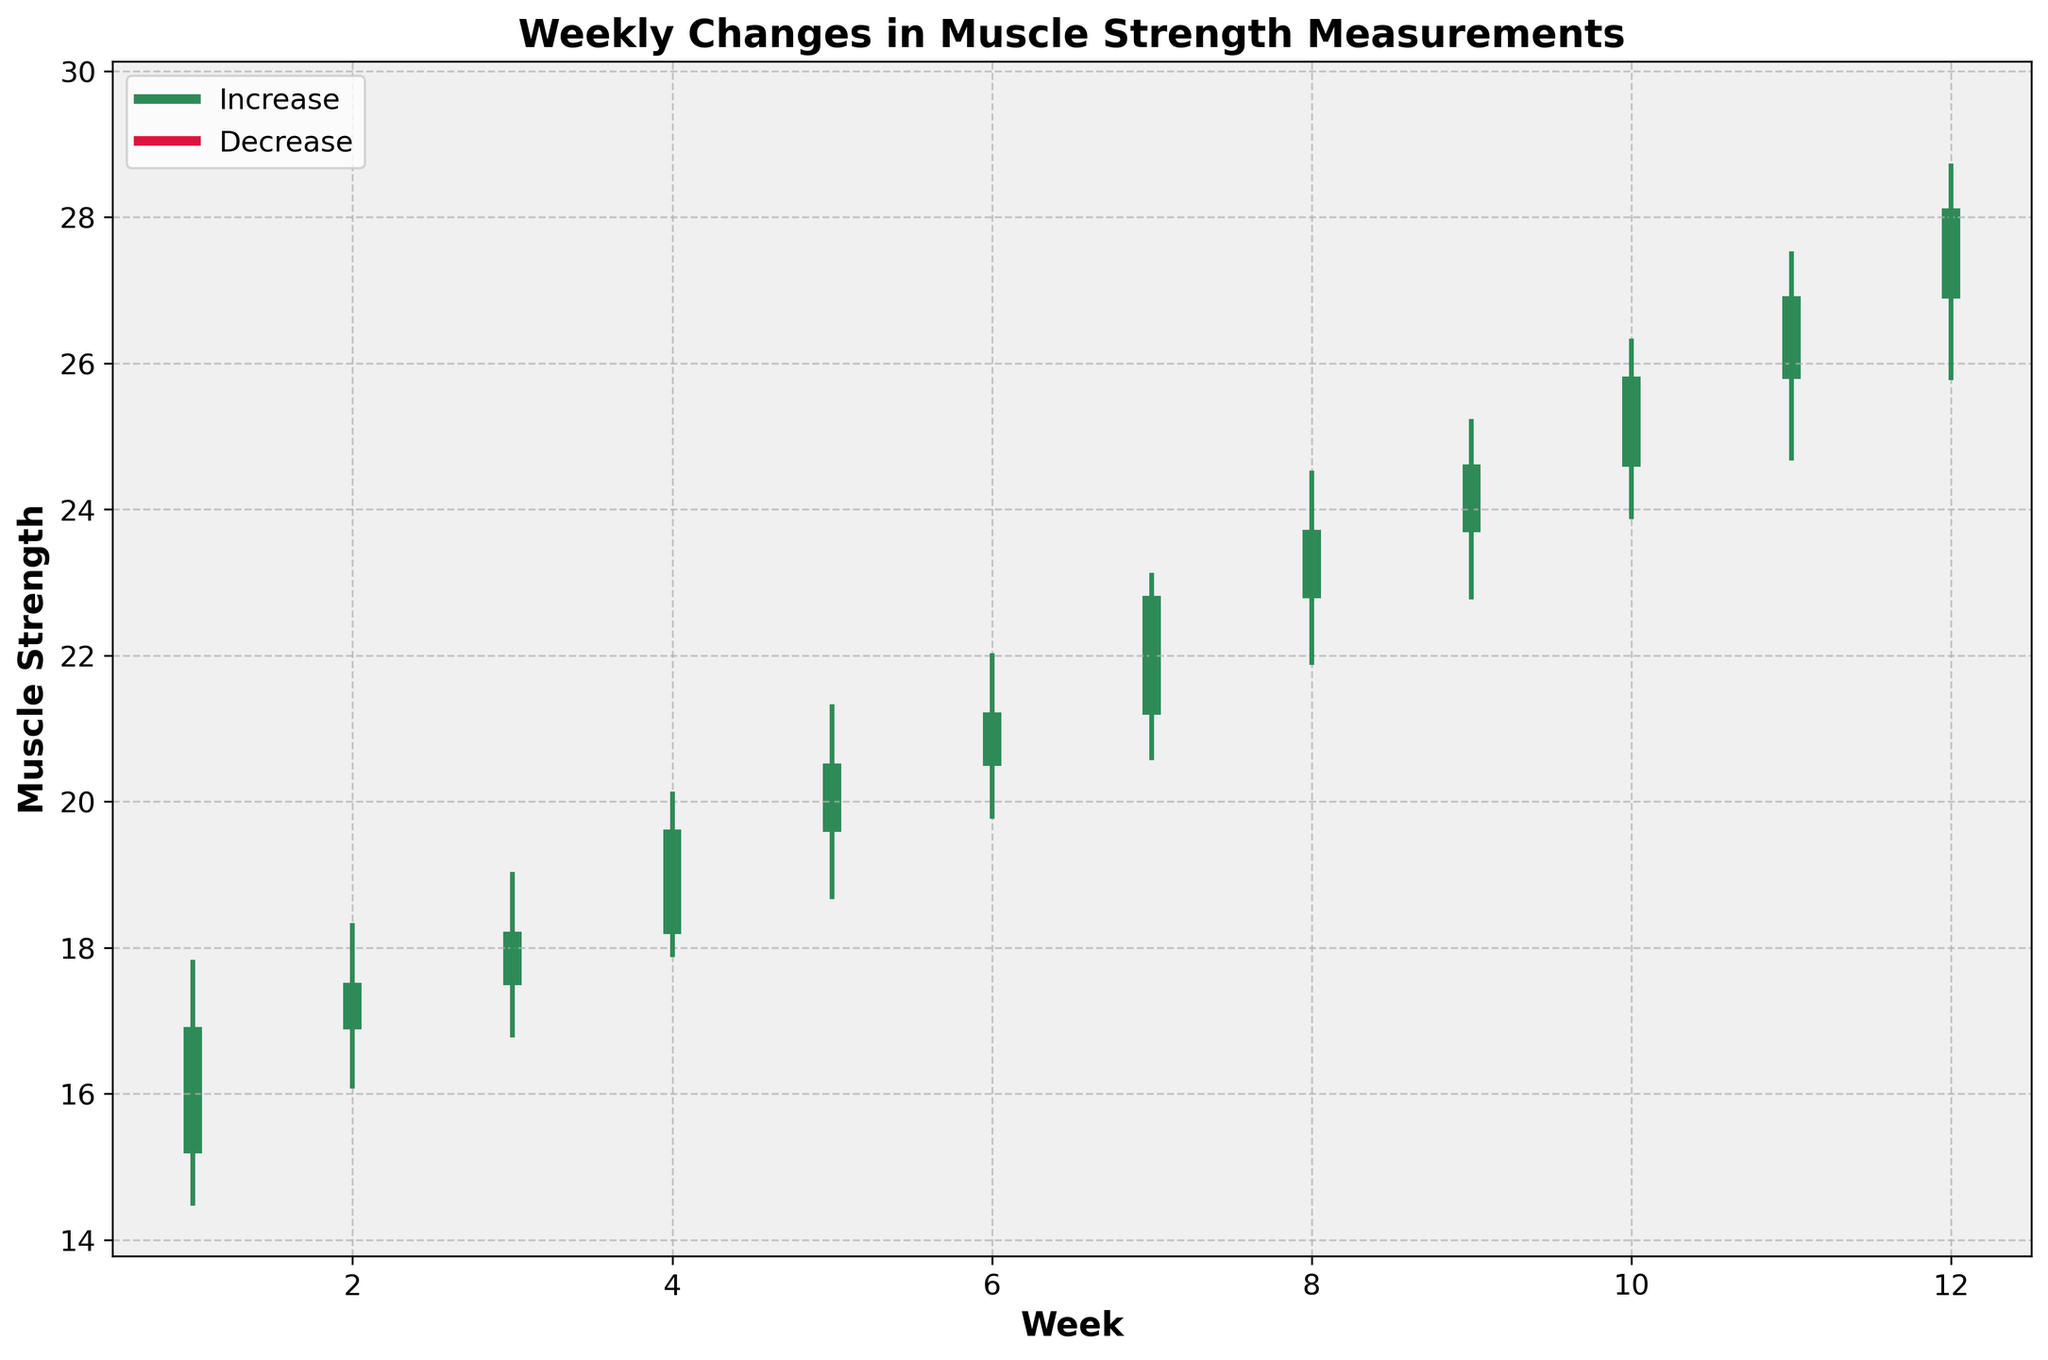what is the title of the chart? The title is typically located at the top of the chart. In this case, it reads "Weekly Changes in Muscle Strength Measurements".
Answer: Weekly Changes in Muscle Strength Measurements What is the highest muscle strength recorded in Week 5? To find this, look at the "High" value for Week 5 in the chart. The high value for Week 5 is 21.3.
Answer: 21.3 How many weeks show an increase in muscle strength? An increase in muscle strength is indicated by the closing value being higher than the opening value. Count the weeks where the close is greater than the open. There are 12 weeks where this is true.
Answer: 12 Which week shows the largest single-week increase in muscle strength? For this, calculate the increase for each week by subtracting the week's opening value from the closing value and find the largest. Week 11 shows the largest increase of 1.1 (26.9 - 25.8).
Answer: Week 11 In which week did the muscle strength decrease the most? To find the week with the largest decrease, calculate the difference between the opening and closing values for each week where the closing value is less than the opening value. There are no weeks where muscle strength decreased.
Answer: None What is the average high value over the 12 weeks? Sum up all the "High" values and divide by the number of weeks, which is 12. (17.8 + 18.3 + 19.0 + 20.1 + 21.3 + 22.0 + 23.1 + 24.5 + 25.2 + 26.3 + 27.5 + 28.7) / 12 = 22.45
Answer: 22.45 Compare the closing muscle strength in Week 6 and Week 7, which is higher? Look at the close values for Week 6 and Week 7. The close for Week 6 is 21.2, and for Week 7, it is 22.8. Week 7 has the higher close.
Answer: Week 7 What’s the difference between the highest and lowest muscle strength recorded in Week 12? Subtract the low value from the high value in Week 12. 28.7 - 25.8 = 2.9
Answer: 2.9 On average, how much did muscle strength increase per week over the 12 weeks? Find the difference between the closing and opening values for each week, sum them, and then divide by 12. (16.9-15.2 + 17.5-16.9 + 18.2-17.5 + 19.6-18.2 + 20.5-19.6 + 21.2-20.5 + 22.8-21.2 + 23.7-22.8 + 24.6-23.7 + 25.8-24.6 + 26.9-25.8 + 28.1-26.9) / 12 = 1.12
Answer: 1.12 How many times did the muscle strength's weekly close exceed 24.0? Count the number of weeks where the close value is greater than 24.0. Weeks 10, 11, and 12 have closes of 25.8, 26.9, and 28.1, respectively. So, 3 times.
Answer: 3 